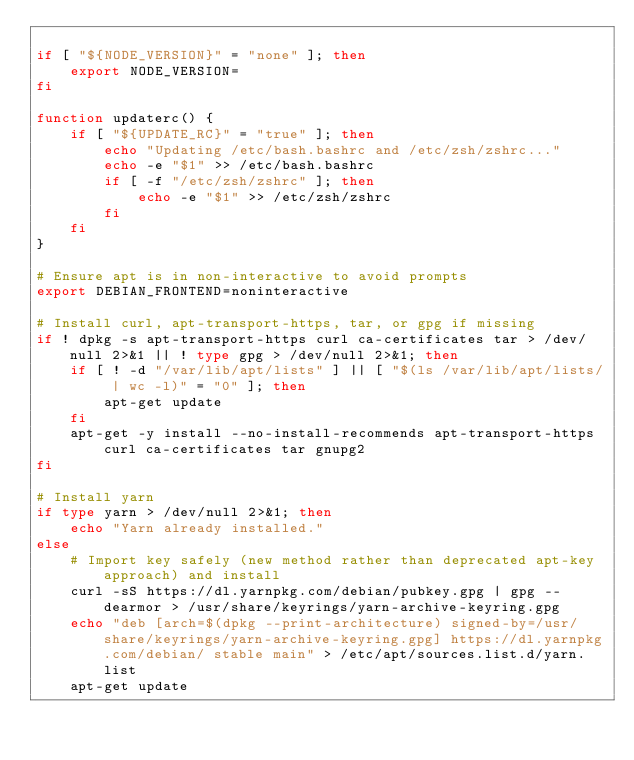<code> <loc_0><loc_0><loc_500><loc_500><_Bash_>
if [ "${NODE_VERSION}" = "none" ]; then
    export NODE_VERSION=
fi

function updaterc() {
    if [ "${UPDATE_RC}" = "true" ]; then
        echo "Updating /etc/bash.bashrc and /etc/zsh/zshrc..."
        echo -e "$1" >> /etc/bash.bashrc
        if [ -f "/etc/zsh/zshrc" ]; then
            echo -e "$1" >> /etc/zsh/zshrc
        fi
    fi
}

# Ensure apt is in non-interactive to avoid prompts
export DEBIAN_FRONTEND=noninteractive

# Install curl, apt-transport-https, tar, or gpg if missing
if ! dpkg -s apt-transport-https curl ca-certificates tar > /dev/null 2>&1 || ! type gpg > /dev/null 2>&1; then
    if [ ! -d "/var/lib/apt/lists" ] || [ "$(ls /var/lib/apt/lists/ | wc -l)" = "0" ]; then
        apt-get update
    fi
    apt-get -y install --no-install-recommends apt-transport-https curl ca-certificates tar gnupg2
fi

# Install yarn
if type yarn > /dev/null 2>&1; then
    echo "Yarn already installed."
else
    # Import key safely (new method rather than deprecated apt-key approach) and install
    curl -sS https://dl.yarnpkg.com/debian/pubkey.gpg | gpg --dearmor > /usr/share/keyrings/yarn-archive-keyring.gpg
    echo "deb [arch=$(dpkg --print-architecture) signed-by=/usr/share/keyrings/yarn-archive-keyring.gpg] https://dl.yarnpkg.com/debian/ stable main" > /etc/apt/sources.list.d/yarn.list
    apt-get update</code> 